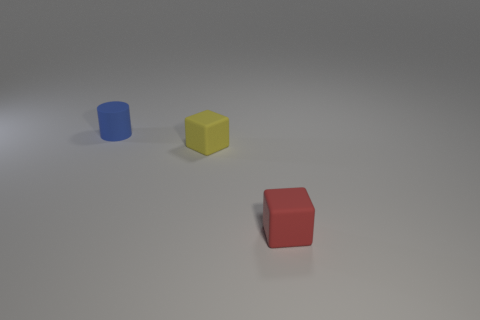Is there any other thing that is the same shape as the small blue object?
Provide a short and direct response. No. There is a cylinder that is the same material as the yellow block; what is its color?
Your answer should be very brief. Blue. Are there fewer tiny cylinders behind the cylinder than rubber objects behind the tiny yellow rubber object?
Keep it short and to the point. Yes. How many other tiny cylinders are the same color as the small cylinder?
Keep it short and to the point. 0. What number of small things are in front of the cylinder and on the left side of the red matte object?
Ensure brevity in your answer.  1. There is a thing that is right of the matte block that is behind the red block; what is its material?
Your answer should be very brief. Rubber. Is there another block that has the same material as the yellow block?
Ensure brevity in your answer.  Yes. What material is the red cube that is the same size as the yellow matte thing?
Make the answer very short. Rubber. There is a cube that is behind the red rubber object; is there a thing that is behind it?
Offer a very short reply. Yes. There is a tiny yellow object; does it have the same shape as the object left of the tiny yellow matte cube?
Ensure brevity in your answer.  No. 